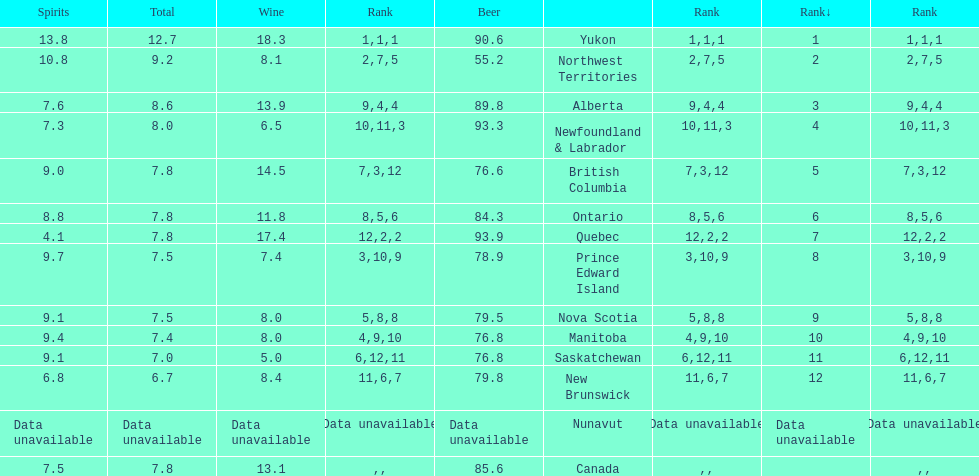How many litres do individuals in yukon consume in spirits per year? 12.7. 